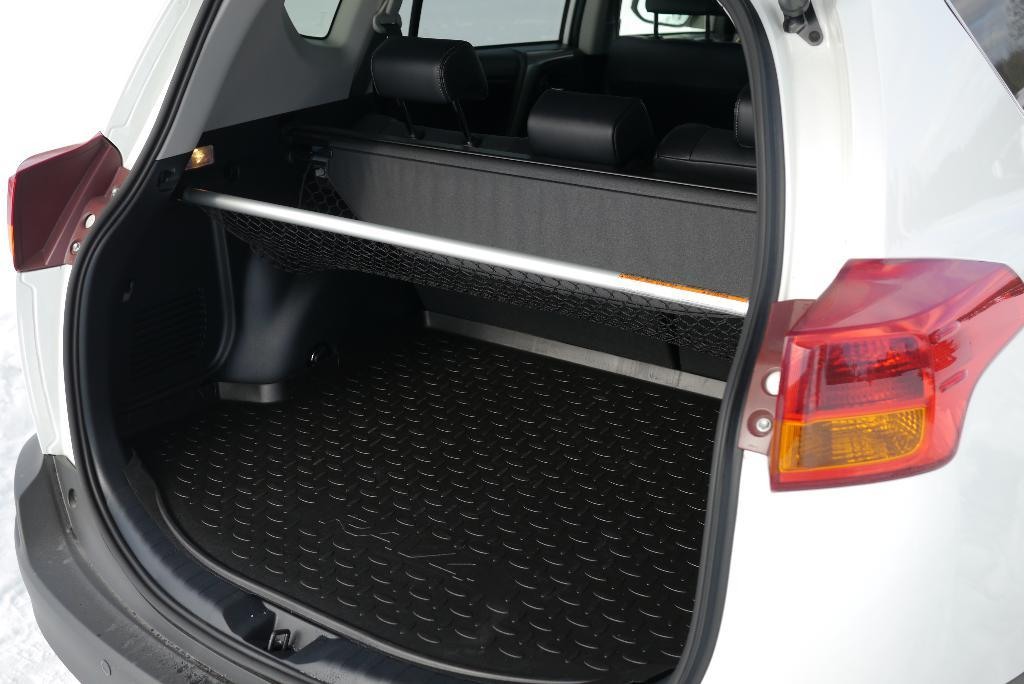What part of the car is visible in the image? There is a car trunk in the image. What color is the car? The car is white. Where are the indicator light and danger light located on the car? They are both on the right side of the car. How many beds are visible in the image? There are no beds present in the image; it features a car trunk. What type of clock is shown in the image? There is no clock present in the image. 